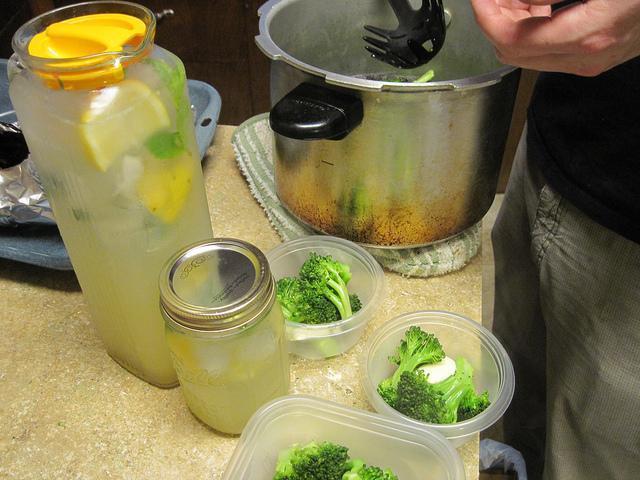How many cups of broccoli are there?
Give a very brief answer. 3. How many bottles can you see?
Give a very brief answer. 2. How many bowls are in the picture?
Give a very brief answer. 3. How many broccolis can be seen?
Give a very brief answer. 3. How many boats are to the right of the stop sign?
Give a very brief answer. 0. 